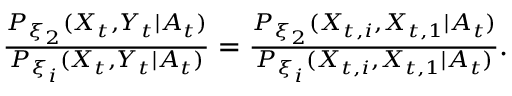Convert formula to latex. <formula><loc_0><loc_0><loc_500><loc_500>\begin{array} { r } { \frac { P _ { \xi _ { 2 } } ( X _ { t } , Y _ { t } | A _ { t } ) } { P _ { \xi _ { i } } ( X _ { t } , Y _ { t } | A _ { t } ) } = \frac { P _ { \xi _ { 2 } } ( X _ { t , i } , X _ { t , 1 } | A _ { t } ) } { P _ { \xi _ { i } } ( X _ { t , i } , X _ { t , 1 } | A _ { t } ) } . } \end{array}</formula> 